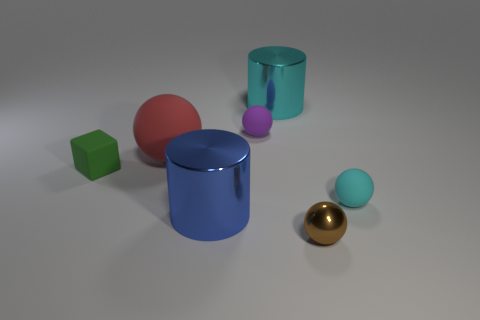How big is the green rubber object left of the large shiny cylinder in front of the metallic thing behind the big red sphere?
Offer a very short reply. Small. Do the big cylinder behind the big blue metal cylinder and the thing that is in front of the big blue shiny cylinder have the same material?
Ensure brevity in your answer.  Yes. What number of other things are there of the same color as the cube?
Make the answer very short. 0. What number of objects are either objects in front of the green thing or metal objects in front of the purple object?
Provide a short and direct response. 3. How big is the sphere to the left of the big cylinder on the left side of the purple object?
Provide a short and direct response. Large. How big is the red rubber object?
Keep it short and to the point. Large. There is a matte ball on the right side of the small brown metal object; is it the same color as the big cylinder that is to the right of the small purple thing?
Your response must be concise. Yes. How many other things are the same material as the small cyan ball?
Offer a very short reply. 3. Is there a brown matte cube?
Offer a terse response. No. Is the material of the cyan sphere to the right of the tiny green thing the same as the green thing?
Provide a succinct answer. Yes. 